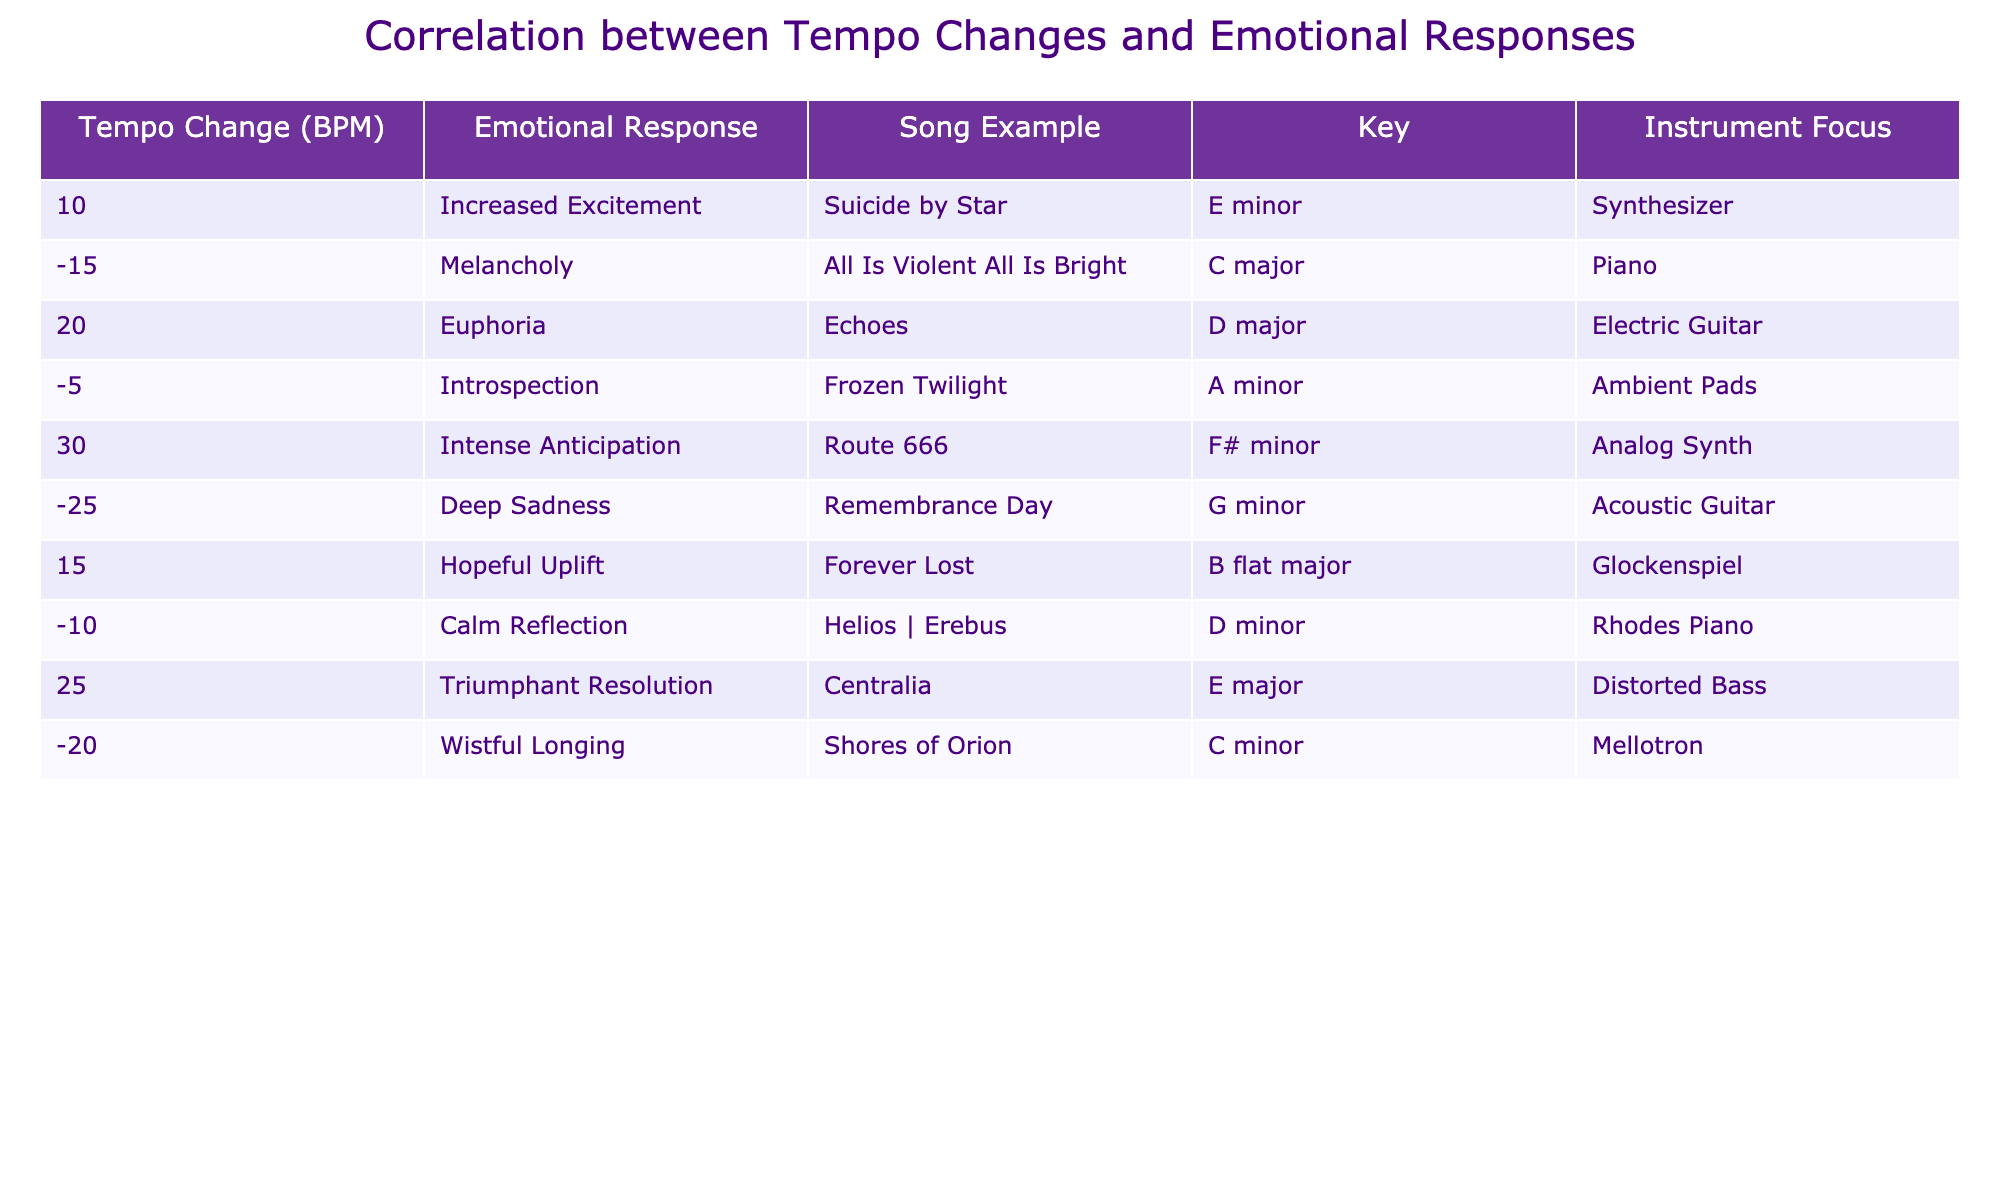What is the emotional response associated with a +30 BPM tempo change? According to the table, a +30 BPM tempo change corresponds to "Intense Anticipation."
Answer: Intense Anticipation Which song example is linked to a -15 BPM change? The table shows that "All Is Violent All Is Bright" is associated with a -15 BPM tempo change.
Answer: All Is Violent All Is Bright Is there a song that has a +25 BPM change? Yes, "Centralia" is listed in the table with a +25 BPM tempo change.
Answer: Yes What is the key of the song that evokes "Deep Sadness"? The table indicates that the song "Remembrance Day" evokes "Deep Sadness" and is in G minor.
Answer: G minor Calculate the total BPM changes associated with the emotional responses "Increased Excitement" and "Euphoria." "Increased Excitement" corresponds to +10 BPM and "Euphoria" corresponds to +20 BPM. Adding these together gives +10 + +20 = +30 BPM.
Answer: +30 BPM How many songs are linked to a negative tempo change? The table lists 5 songs with negative tempo changes: "All Is Violent All Is Bright," "Frozen Twilight," "Remembrance Day," "Calm Reflection," and "Shores of Orion."
Answer: 5 songs Which instrument is focused on in the song associated with "Hopeful Uplift"? According to the table, the instrument focus for "Forever Lost," which evokes "Hopeful Uplift," is the Glockenspiel.
Answer: Glockenspiel Is "Suicide by Star" a song that has a decrease in tempo? No, "Suicide by Star" has a tempo increase of +10 BPM.
Answer: No What is the average BPM change for songs evoking melancholy or deep sadness? Melancholy corresponds to -15 BPM from "All Is Violent All Is Bright" and deep sadness corresponds to -25 BPM from "Remembrance Day." The average is (-15 - 25) / 2 = -20 BPM.
Answer: -20 BPM Identify the emotional response associated with the highest BPM change. The table shows that the highest BPM change is +30, which is associated with "Intense Anticipation."
Answer: Intense Anticipation 